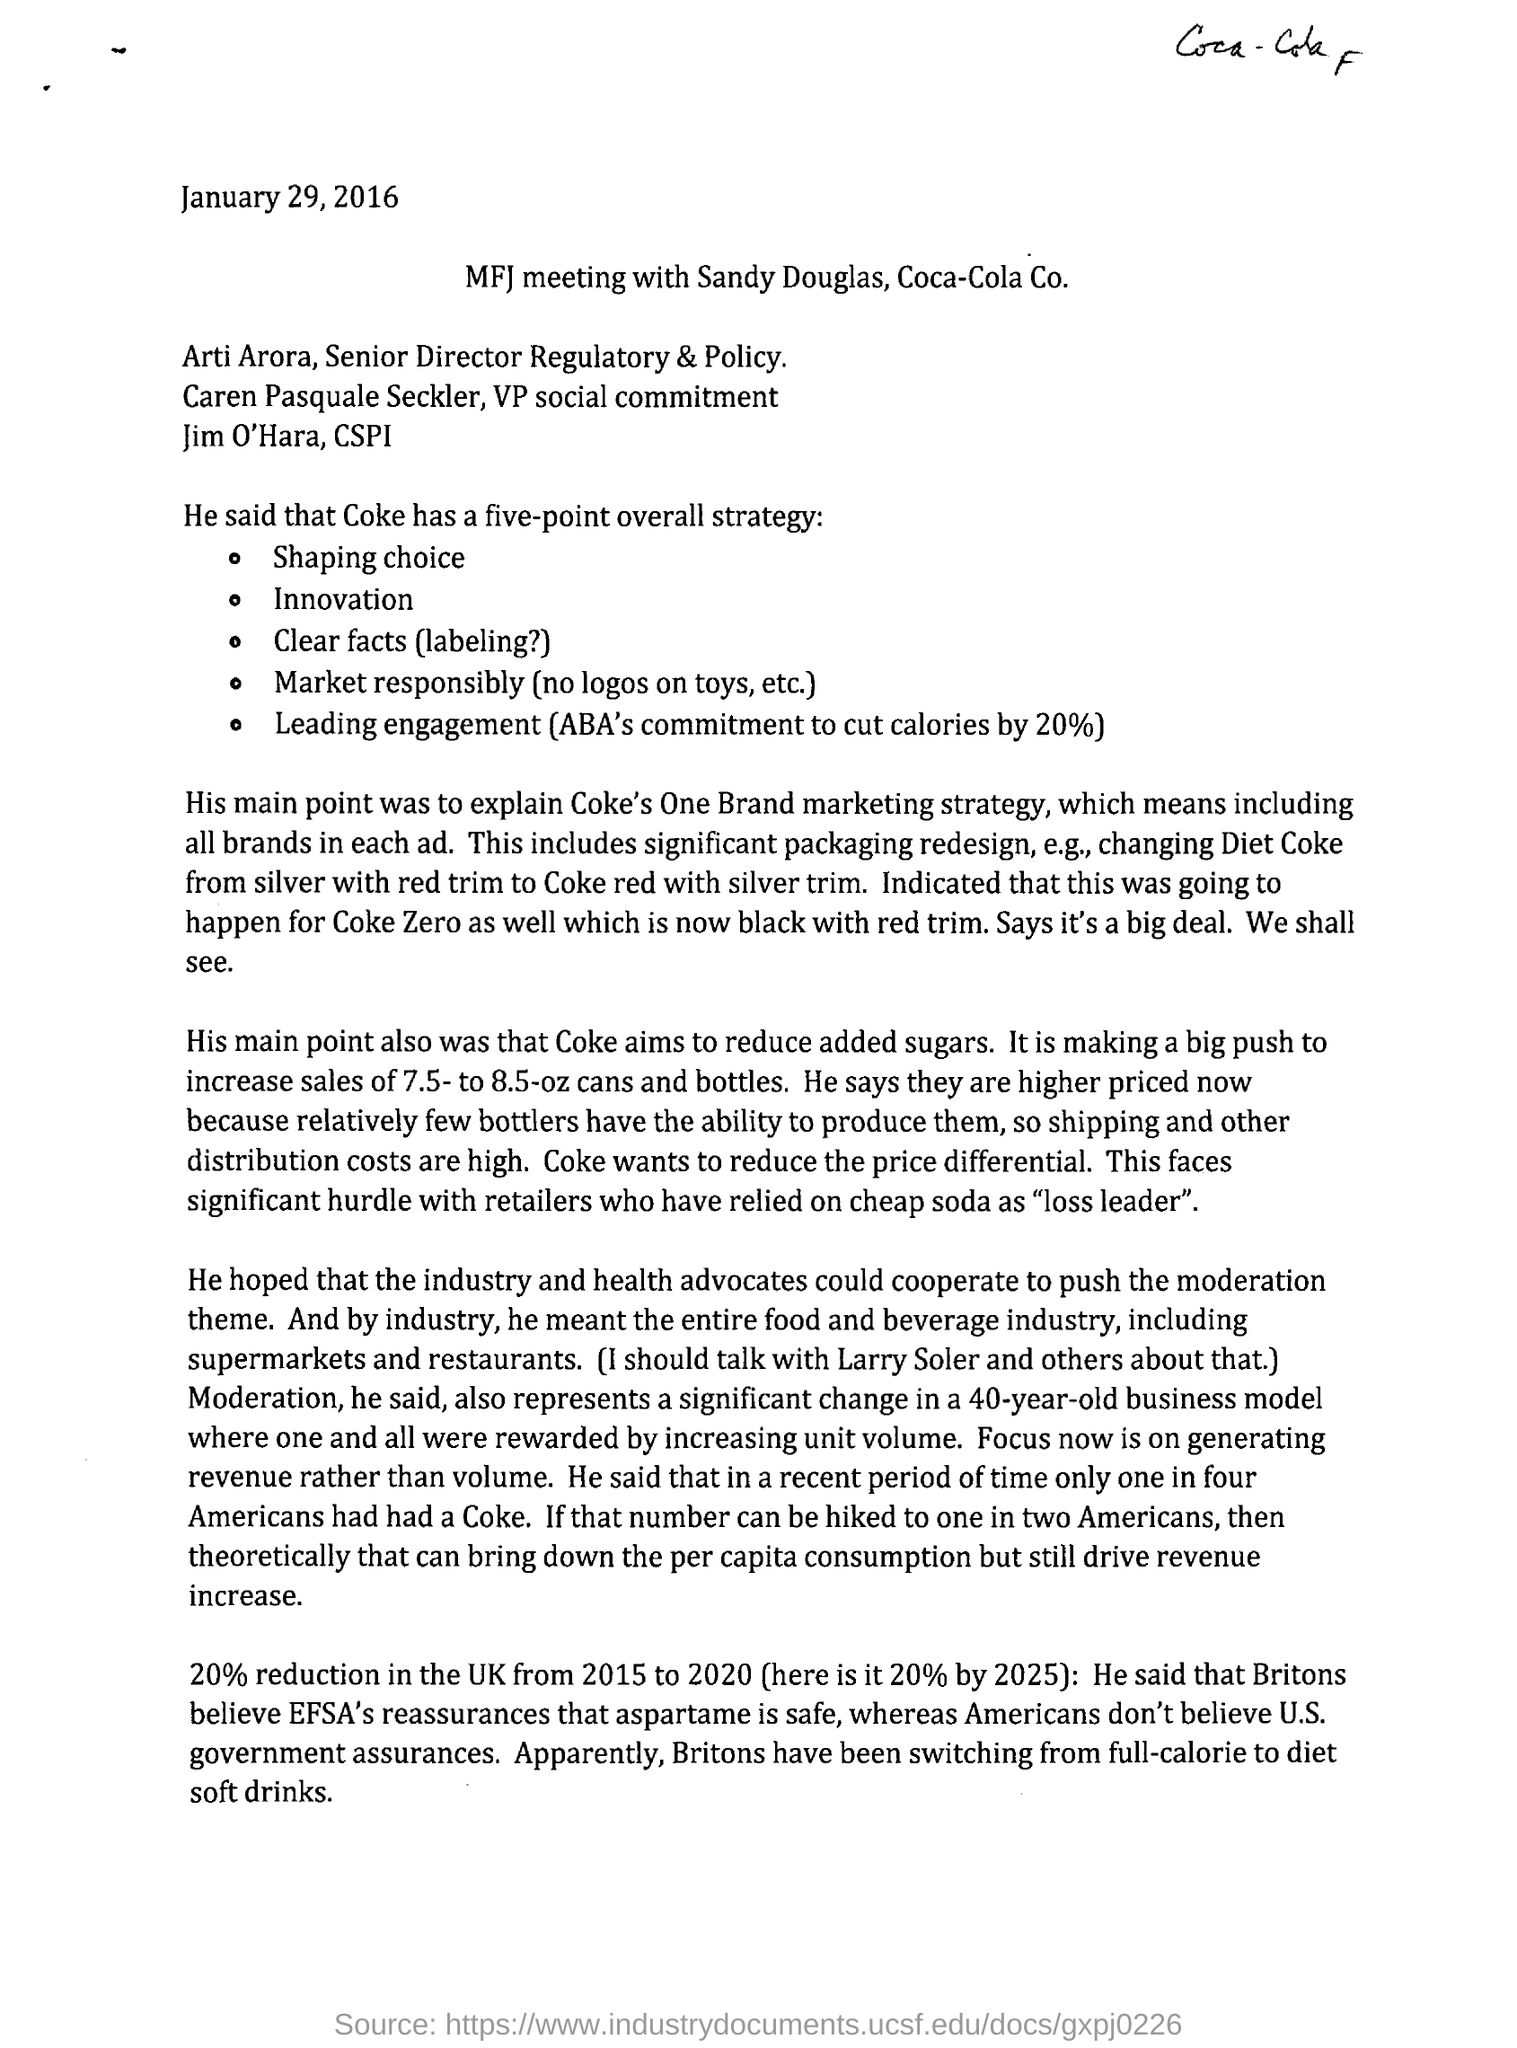What is the date mentioned on the document?
Provide a short and direct response. January 29, 2016. With whom is the meeting being conducted?
Provide a succinct answer. Sandy Douglas. What is the date mentioned in the header of the document?
Provide a short and direct response. January 29, 2016. 